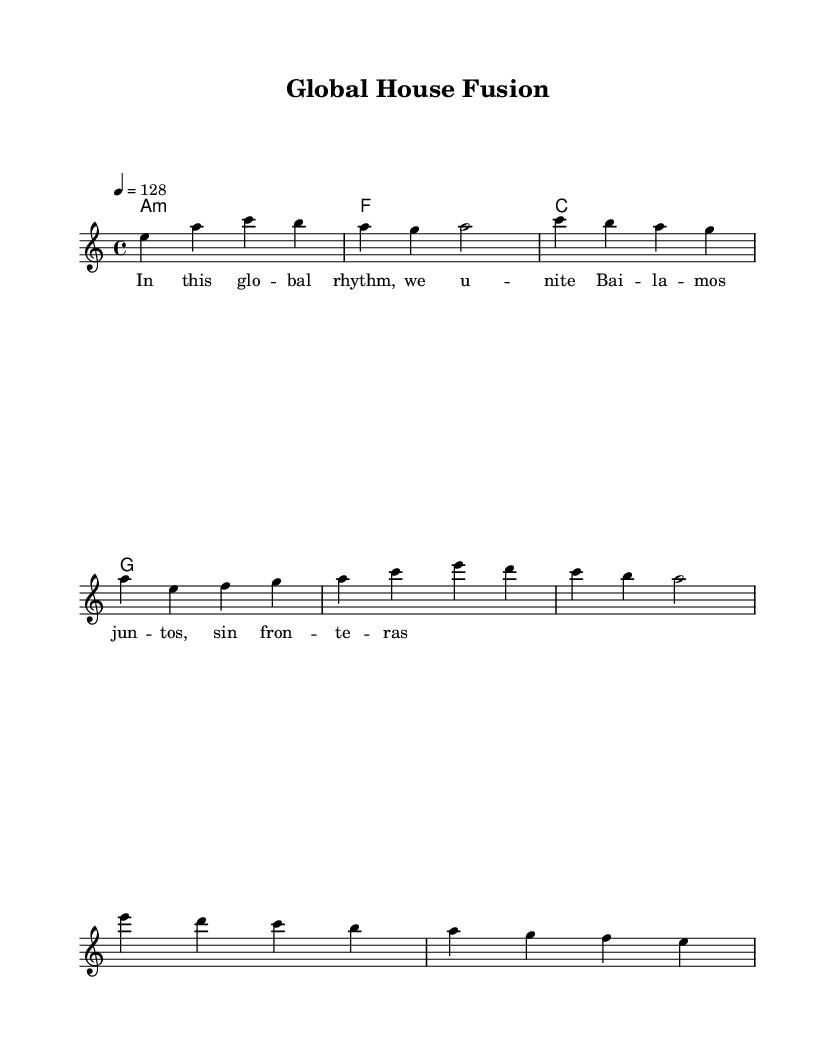What is the key signature of this music? The key signature is A minor, indicated by the absence of any sharps or flats in the music notation.
Answer: A minor What is the time signature of this music? The time signature found in the sheet music is 4/4, which is specified at the beginning of the score.
Answer: 4/4 What is the tempo marking of this piece? The tempo marking specifies that this piece should be played at a tempo of 128 beats per minute, which is indicated at the beginning of the score.
Answer: 128 How many measures are there in the melody? Counting the individual measures in the melody from the sheet music, there are a total of 8 measures.
Answer: 8 What is the mood conveyed by the lyrics? The lyrics express unity and celebration, conveyed through phrases like "In this global rhythm, we unite." This indicates a positive and energetic mood typical of House music.
Answer: Unity Which chord follows the A minor chord in the harmonies? The chord directly following the A minor chord in the harmonies is the F major chord, as shown in the chord changes.
Answer: F major What is the language reflected in the verse lyrics? The verse lyrics incorporate both English and Spanish, evident in phrases like "In this global rhythm" and "Bailamos juntos, sin fronteras." This multilingual aspect highlights the international feel of the piece.
Answer: English and Spanish 